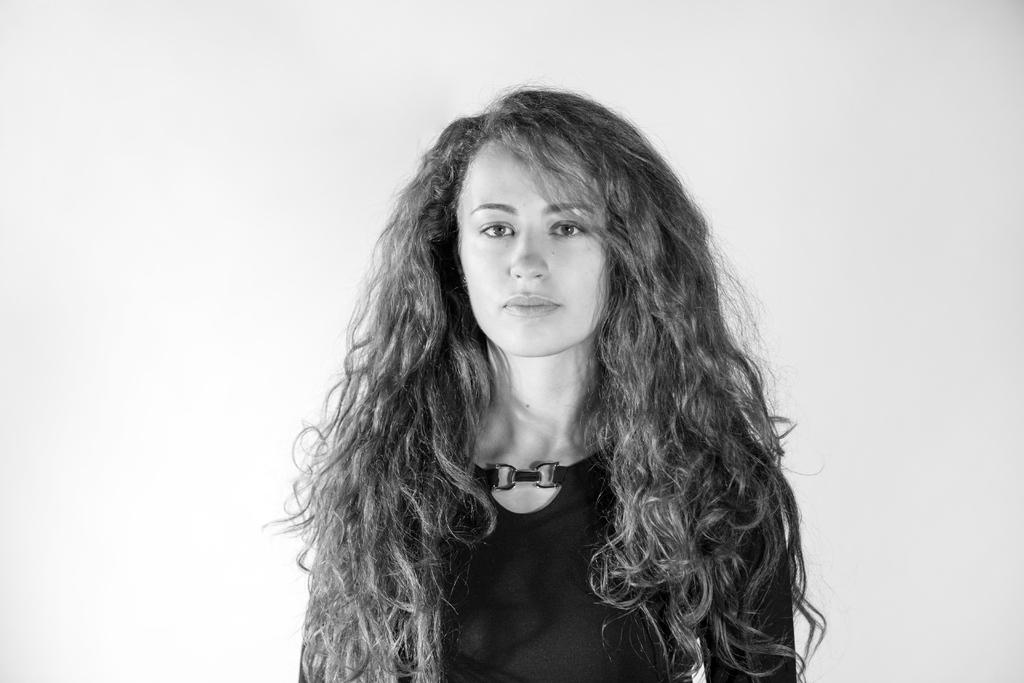What is the main subject in the foreground of the image? There is a person in the foreground of the image. What is the person wearing in the image? The person is wearing a black color dress. What is the color of the background in the image? The background of the image is white in color. Can you hear the horn in the image? There is no horn present in the image, so it cannot be heard. 